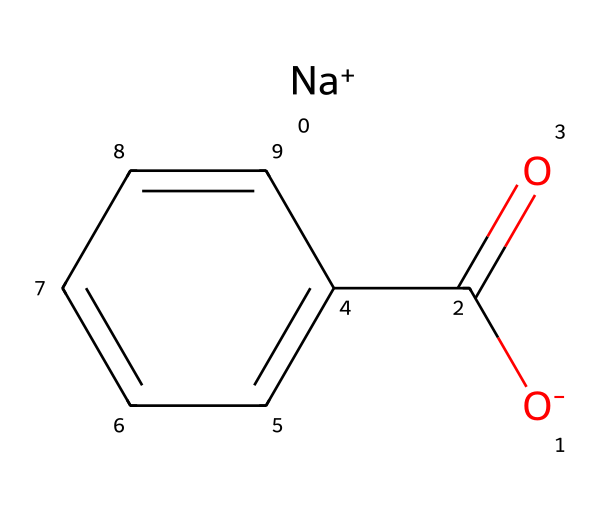How many carbon atoms are present in sodium benzoate? By examining the SMILES representation, we can identify the aromatic ring (c1ccccc1) which indicates there are six carbon atoms in the ring plus one carbon from the carboxylate group (C(=O)), totaling seven carbon atoms.
Answer: seven What type of functional group is present in sodium benzoate? The structure includes a carboxylate group, which is indicated by C(=O)O, where it shows a carbon double-bonded to an oxygen and single-bonded to another oxygen. This characteristic defines it as a carboxylate.
Answer: carboxylate What is the charge of the sodium ion in sodium benzoate? The inclusion of [Na+] in the SMILES notation indicates that there is a sodium ion present, which is known to carry a positive charge.
Answer: positive What is the overall polarity of sodium benzoate? Sodium benzoate has both polar and non-polar characteristics; the carboxylate group is polar, while the benzene ring structure is relatively non-polar. The presence of the ionic sodium also contributes to its solubility in water, enhancing its overall polarity.
Answer: polar How many hydrogen atoms are present in sodium benzoate? By analyzing the structure derived from the SMILES, the benzene ring (c1ccccc1) does not contribute hydrogen atoms due to its formation with other carbons, and the carboxylate group (C(=O)O) does not have an associated hydrogen in the ionic form. Therefore, there are five hydrogen atoms attached to the benzene ring.
Answer: five Is sodium benzoate a salt or an acid? The presence of the sodium ion along with the carboxylate part (C(=O), O-) indicates that sodium benzoate is a salt because it is derived from the neutralization of benzoic acid with sodium hydroxide.
Answer: salt 